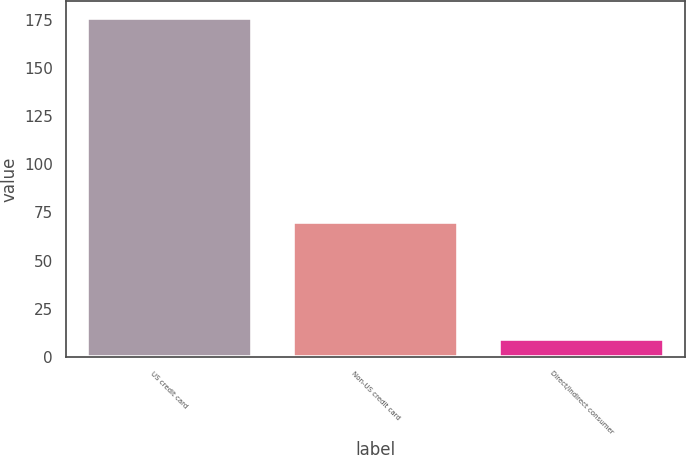<chart> <loc_0><loc_0><loc_500><loc_500><bar_chart><fcel>US credit card<fcel>Non-US credit card<fcel>Direct/Indirect consumer<nl><fcel>176<fcel>70<fcel>9<nl></chart> 